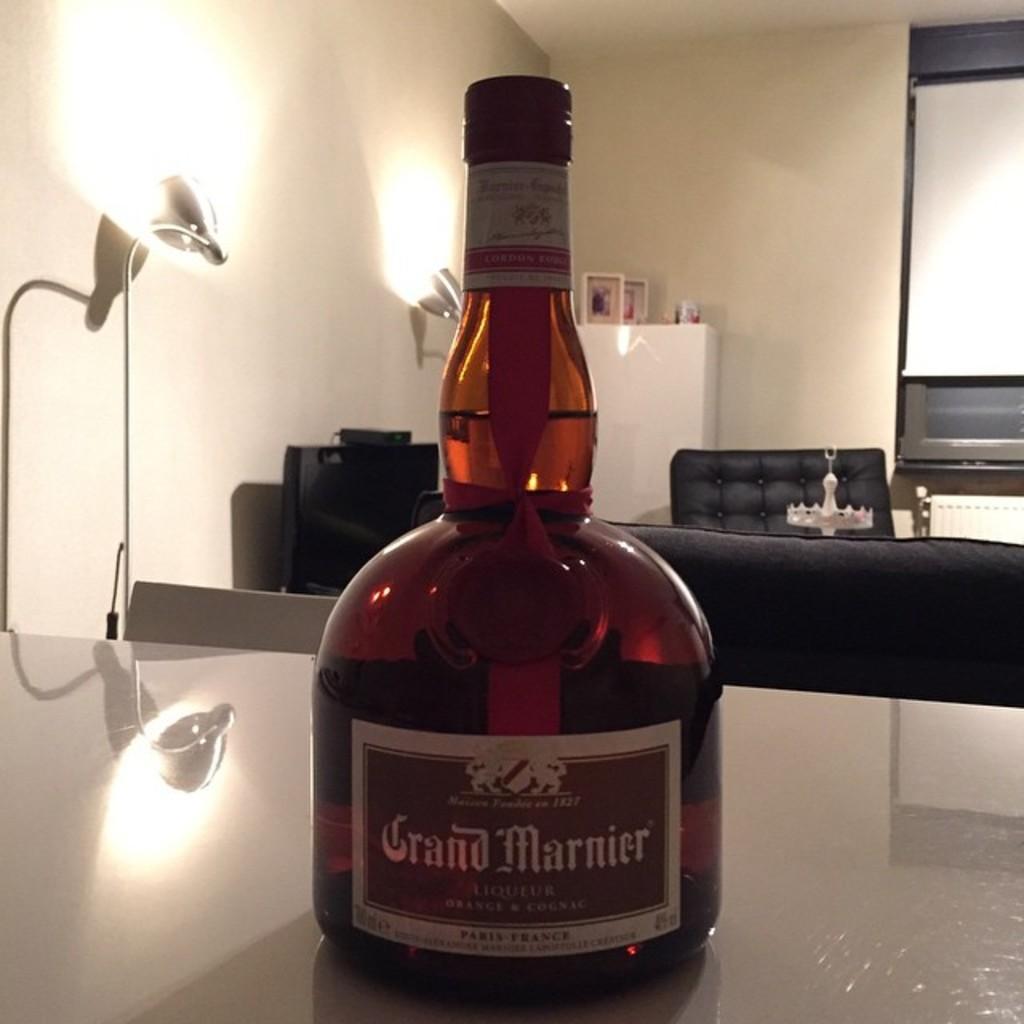How would you summarize this image in a sentence or two? In this image we have beer bottle placed in a table , at back ground we have lights , cupboard , chair , another table , screen and photo frames in the cupboard. 